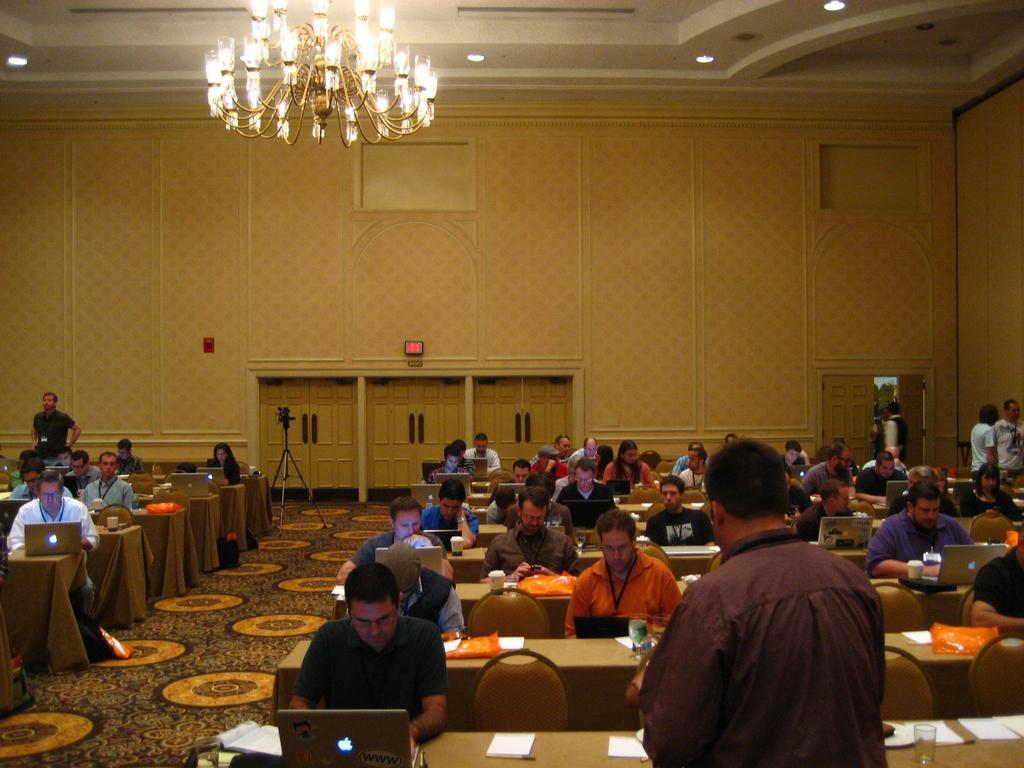Please provide a concise description of this image. In this picture we can see some people are sitting on chairs and some people are standing on the floor. In front of the people there are tables, which are covered with clothes. On the tables there are laptops, glasses, cups, papers and some objects. Behind the people, it looks like a camera on the tripod stand. Behind the camera there are some boards on the wall. At the top there are ceiling lights and a chandelier. 